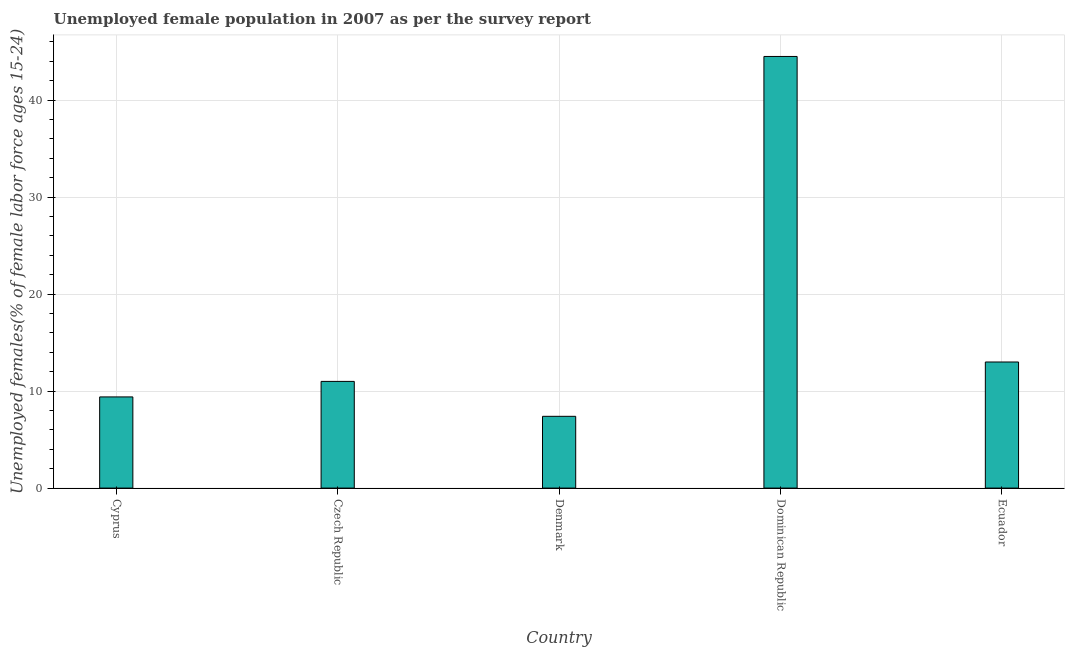What is the title of the graph?
Provide a succinct answer. Unemployed female population in 2007 as per the survey report. What is the label or title of the X-axis?
Give a very brief answer. Country. What is the label or title of the Y-axis?
Provide a succinct answer. Unemployed females(% of female labor force ages 15-24). What is the unemployed female youth in Cyprus?
Make the answer very short. 9.4. Across all countries, what is the maximum unemployed female youth?
Give a very brief answer. 44.5. Across all countries, what is the minimum unemployed female youth?
Make the answer very short. 7.4. In which country was the unemployed female youth maximum?
Keep it short and to the point. Dominican Republic. In which country was the unemployed female youth minimum?
Your answer should be very brief. Denmark. What is the sum of the unemployed female youth?
Give a very brief answer. 85.3. What is the difference between the unemployed female youth in Cyprus and Dominican Republic?
Offer a very short reply. -35.1. What is the average unemployed female youth per country?
Give a very brief answer. 17.06. What is the median unemployed female youth?
Make the answer very short. 11. In how many countries, is the unemployed female youth greater than 38 %?
Your answer should be very brief. 1. What is the ratio of the unemployed female youth in Denmark to that in Dominican Republic?
Provide a succinct answer. 0.17. Is the difference between the unemployed female youth in Cyprus and Denmark greater than the difference between any two countries?
Ensure brevity in your answer.  No. What is the difference between the highest and the second highest unemployed female youth?
Ensure brevity in your answer.  31.5. Is the sum of the unemployed female youth in Czech Republic and Ecuador greater than the maximum unemployed female youth across all countries?
Ensure brevity in your answer.  No. What is the difference between the highest and the lowest unemployed female youth?
Ensure brevity in your answer.  37.1. How many bars are there?
Your answer should be very brief. 5. What is the difference between two consecutive major ticks on the Y-axis?
Give a very brief answer. 10. What is the Unemployed females(% of female labor force ages 15-24) of Cyprus?
Your response must be concise. 9.4. What is the Unemployed females(% of female labor force ages 15-24) of Denmark?
Your answer should be compact. 7.4. What is the Unemployed females(% of female labor force ages 15-24) of Dominican Republic?
Make the answer very short. 44.5. What is the difference between the Unemployed females(% of female labor force ages 15-24) in Cyprus and Czech Republic?
Your answer should be very brief. -1.6. What is the difference between the Unemployed females(% of female labor force ages 15-24) in Cyprus and Denmark?
Ensure brevity in your answer.  2. What is the difference between the Unemployed females(% of female labor force ages 15-24) in Cyprus and Dominican Republic?
Offer a terse response. -35.1. What is the difference between the Unemployed females(% of female labor force ages 15-24) in Cyprus and Ecuador?
Provide a short and direct response. -3.6. What is the difference between the Unemployed females(% of female labor force ages 15-24) in Czech Republic and Dominican Republic?
Give a very brief answer. -33.5. What is the difference between the Unemployed females(% of female labor force ages 15-24) in Denmark and Dominican Republic?
Provide a succinct answer. -37.1. What is the difference between the Unemployed females(% of female labor force ages 15-24) in Dominican Republic and Ecuador?
Offer a terse response. 31.5. What is the ratio of the Unemployed females(% of female labor force ages 15-24) in Cyprus to that in Czech Republic?
Your answer should be compact. 0.85. What is the ratio of the Unemployed females(% of female labor force ages 15-24) in Cyprus to that in Denmark?
Offer a terse response. 1.27. What is the ratio of the Unemployed females(% of female labor force ages 15-24) in Cyprus to that in Dominican Republic?
Give a very brief answer. 0.21. What is the ratio of the Unemployed females(% of female labor force ages 15-24) in Cyprus to that in Ecuador?
Provide a succinct answer. 0.72. What is the ratio of the Unemployed females(% of female labor force ages 15-24) in Czech Republic to that in Denmark?
Offer a very short reply. 1.49. What is the ratio of the Unemployed females(% of female labor force ages 15-24) in Czech Republic to that in Dominican Republic?
Give a very brief answer. 0.25. What is the ratio of the Unemployed females(% of female labor force ages 15-24) in Czech Republic to that in Ecuador?
Your answer should be very brief. 0.85. What is the ratio of the Unemployed females(% of female labor force ages 15-24) in Denmark to that in Dominican Republic?
Make the answer very short. 0.17. What is the ratio of the Unemployed females(% of female labor force ages 15-24) in Denmark to that in Ecuador?
Your answer should be very brief. 0.57. What is the ratio of the Unemployed females(% of female labor force ages 15-24) in Dominican Republic to that in Ecuador?
Make the answer very short. 3.42. 